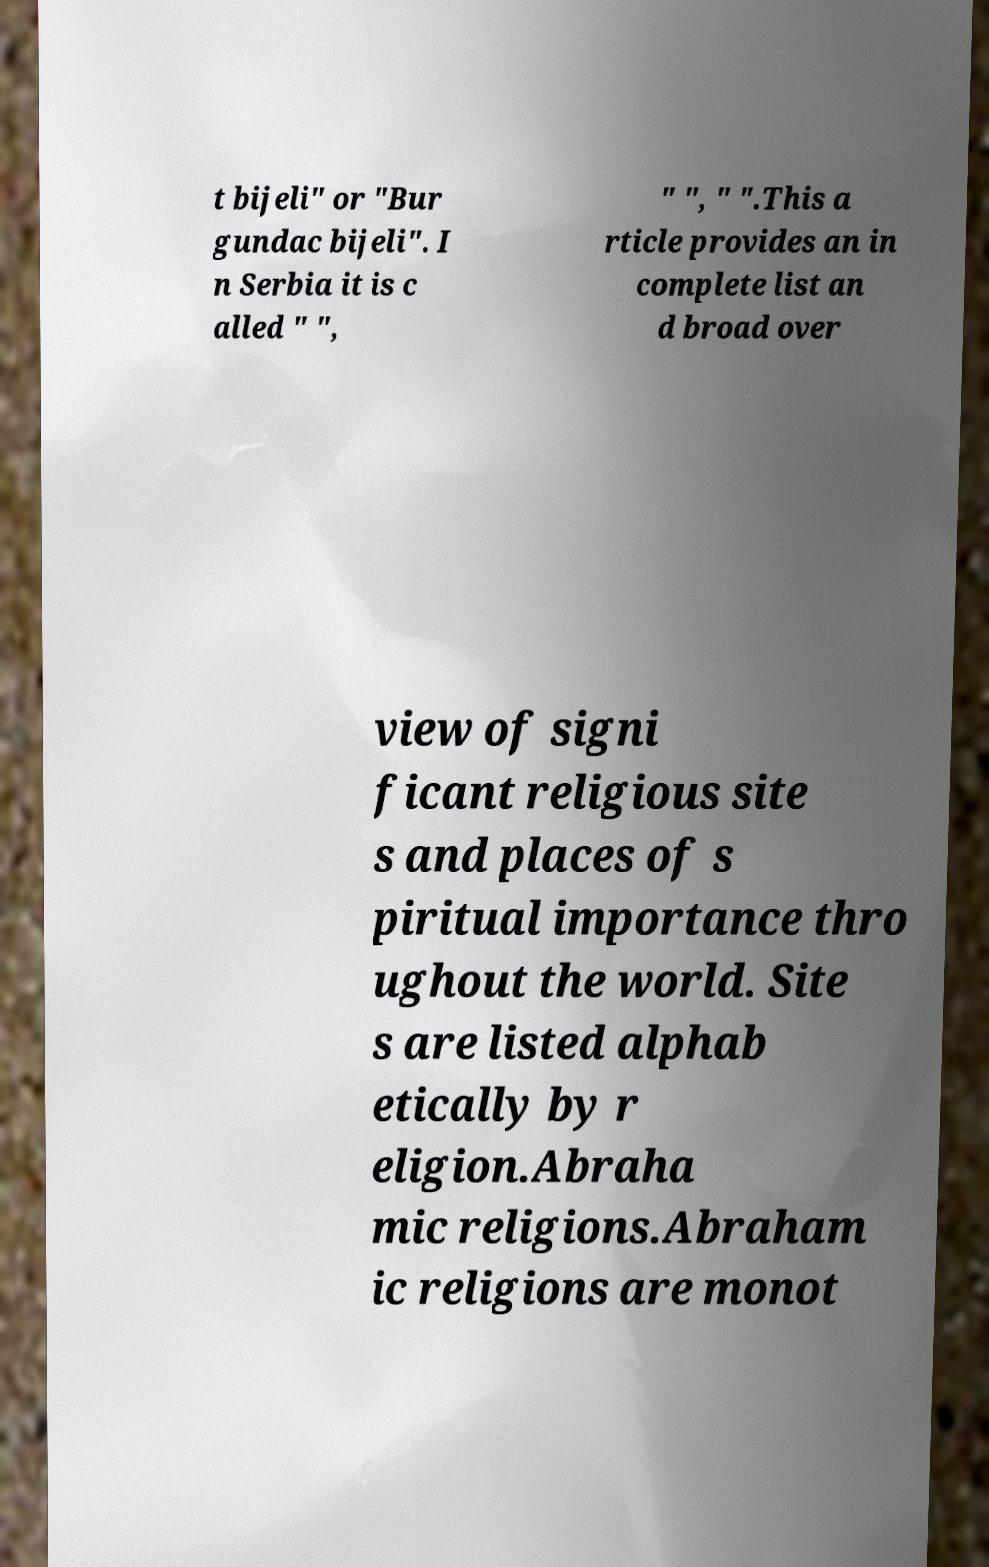For documentation purposes, I need the text within this image transcribed. Could you provide that? t bijeli" or "Bur gundac bijeli". I n Serbia it is c alled " ", " ", " ".This a rticle provides an in complete list an d broad over view of signi ficant religious site s and places of s piritual importance thro ughout the world. Site s are listed alphab etically by r eligion.Abraha mic religions.Abraham ic religions are monot 